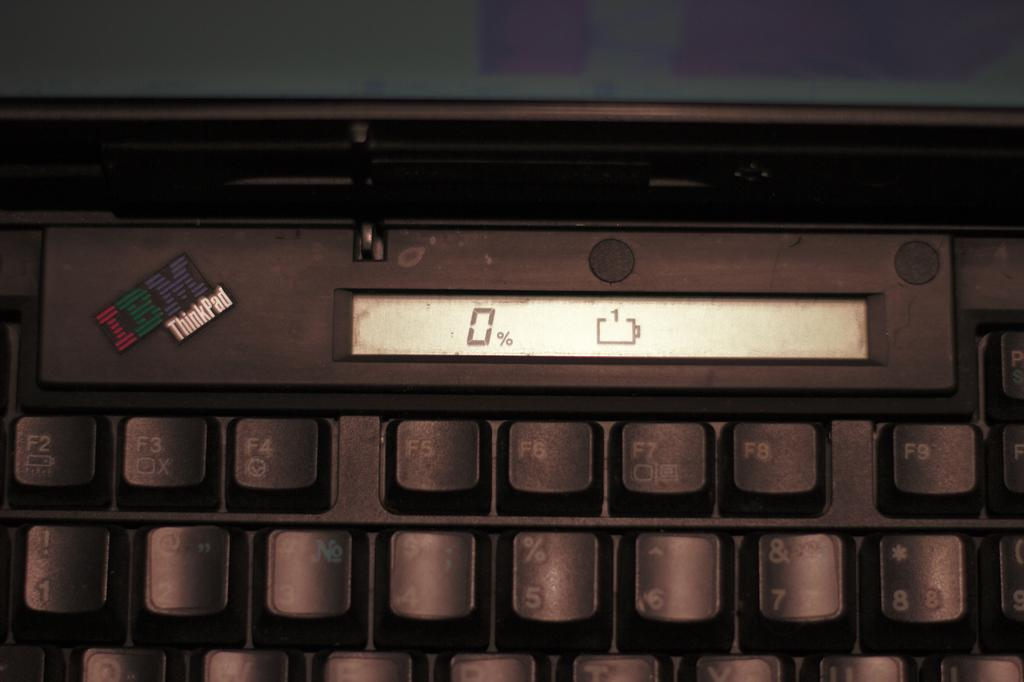<image>
Render a clear and concise summary of the photo. A black keyboard with number 0 on the screen. 